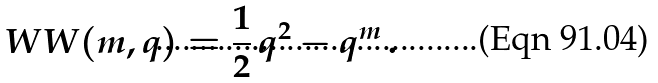<formula> <loc_0><loc_0><loc_500><loc_500>\ W W ( m , q ) = \frac { 1 } { 2 } \, q ^ { 2 } - q ^ { m } \, .</formula> 